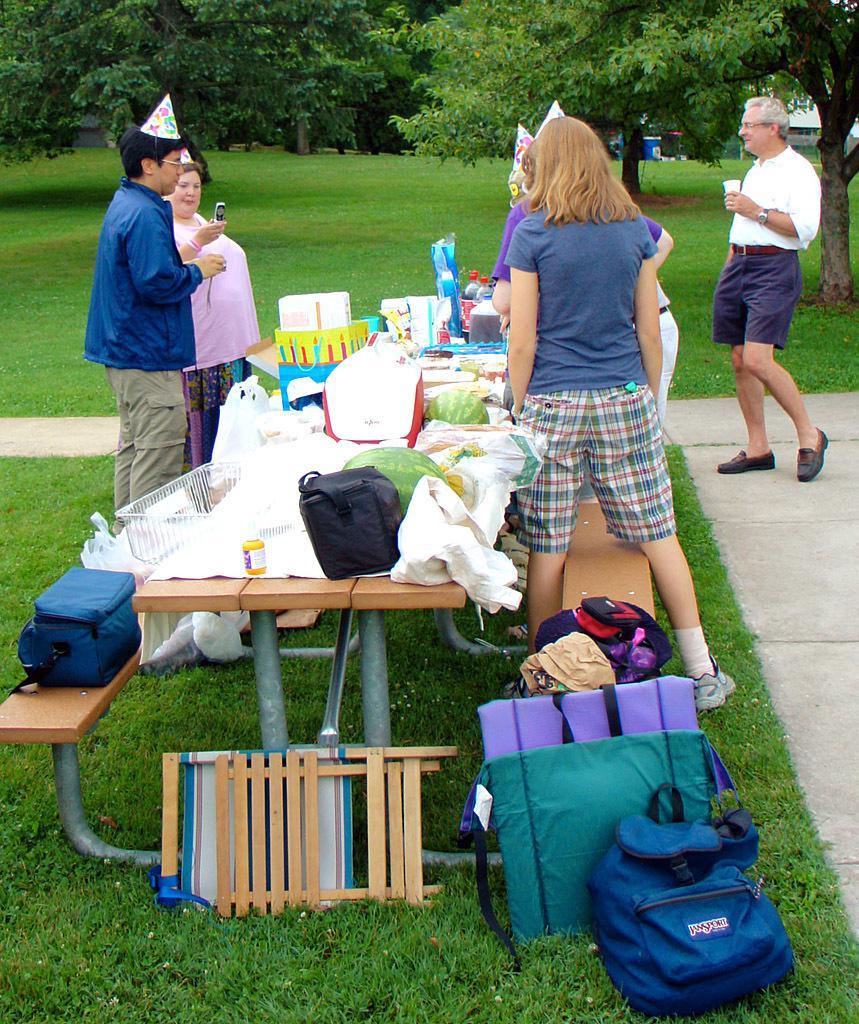In one or two sentences, can you explain what this image depicts? In this picture I can observe some people standing around the table. I can observe few things placed on the table. There is some grass on the ground. In the background there are trees. 